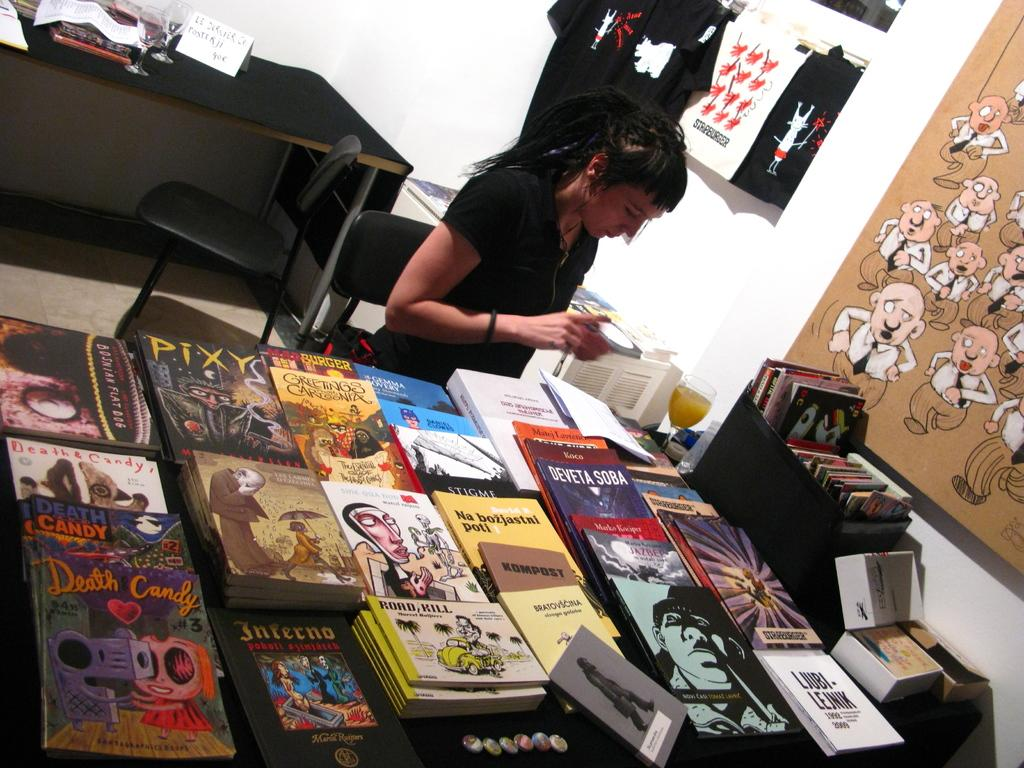What is the main subject of the image? There is a woman standing in the image. What objects are present in the image besides the woman? There are books, chairs, tables, and clothes in the image. What type of stamp can be seen on the woman's forehead in the image? There is no stamp present on the woman's forehead in the image. 